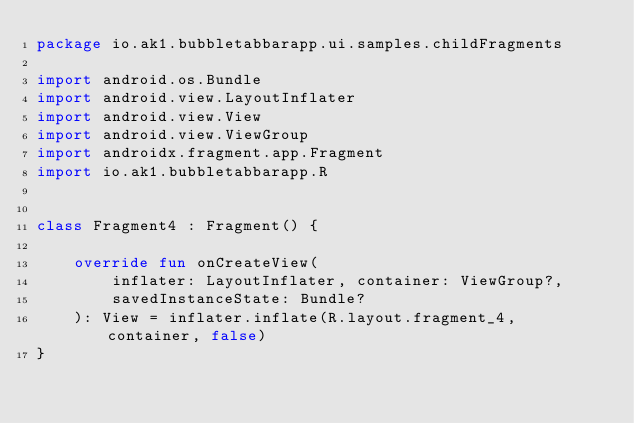Convert code to text. <code><loc_0><loc_0><loc_500><loc_500><_Kotlin_>package io.ak1.bubbletabbarapp.ui.samples.childFragments

import android.os.Bundle
import android.view.LayoutInflater
import android.view.View
import android.view.ViewGroup
import androidx.fragment.app.Fragment
import io.ak1.bubbletabbarapp.R


class Fragment4 : Fragment() {

    override fun onCreateView(
        inflater: LayoutInflater, container: ViewGroup?,
        savedInstanceState: Bundle?
    ): View = inflater.inflate(R.layout.fragment_4, container, false)
}</code> 